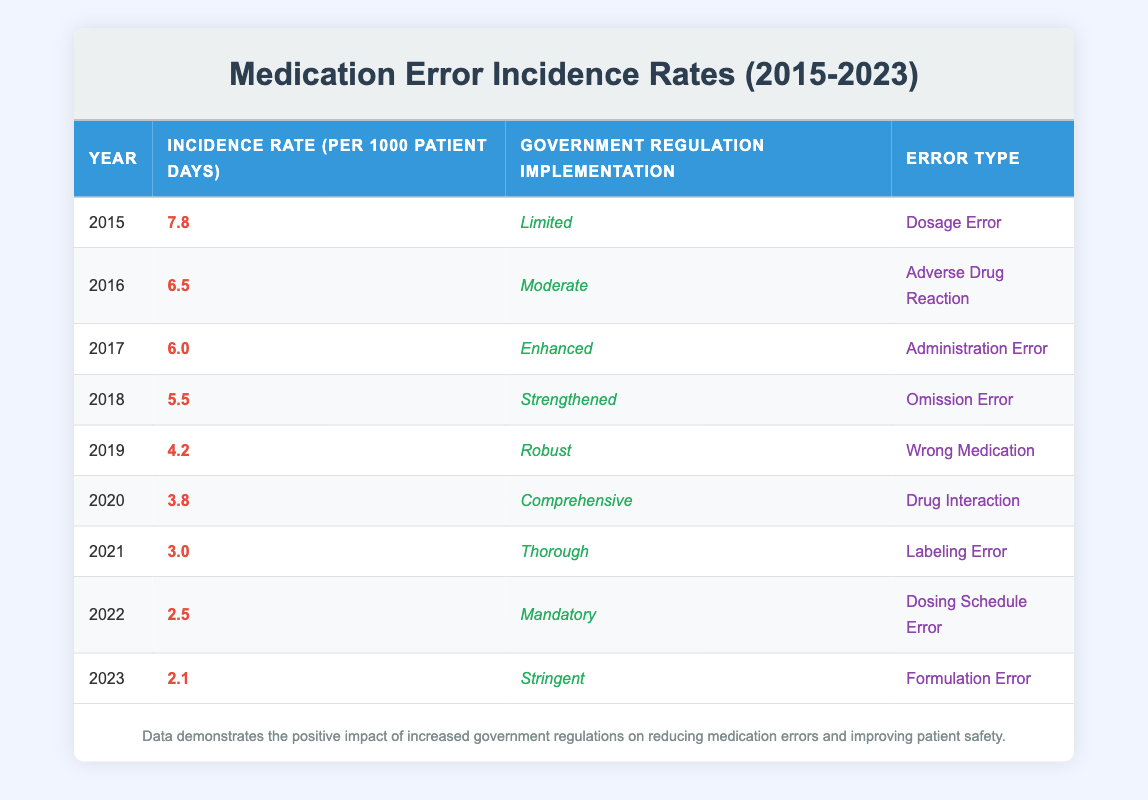What was the incidence rate of medication errors in 2015? The table shows that the incidence rate in 2015 is listed as 7.8 per 1000 patient days.
Answer: 7.8 Which year had the lowest incidence rate of medication errors? From the table, 2023 has the lowest incidence rate at 2.1 per 1000 patient days, which is lower than all other years listed.
Answer: 2023 Is there a correlation between the level of government regulation implementation and the incidence rate? Observing the data, as the level of government regulation implementation increases, the incidence rates generally decrease, indicating a likely inverse relationship.
Answer: Yes What was the difference in incidence rates between 2015 and 2020? To find this, subtract the 2020 rate (3.8) from the 2015 rate (7.8): 7.8 - 3.8 = 4.0. Thus, the difference is 4.0 per 1000 patient days.
Answer: 4.0 What is the type of medication error reported in 2019? The table indicates that the error type for the year 2019 is classified as "Wrong Medication."
Answer: Wrong Medication What is the average incidence rate from 2015 to 2023? First, sum the incidence rates: (7.8 + 6.5 + 6.0 + 5.5 + 4.2 + 3.8 + 3.0 + 2.5 + 2.1) = 39.6. There are 9 years of data, so the average is 39.6 / 9 = 4.4 per 1000 patient days.
Answer: 4.4 Did the implementation of the most stringent government regulation correlate with the highest incidence rates? By observing the table, the most stringent implementation in 2023 shows a low incidence rate of 2.1, thus contradicting the expectation that stringent regulations correlate with high incidence.
Answer: No How many types of medication errors were recorded in total across the years? The table lists distinct error types for each year, totaling 9 different types from 2015 to 2023.
Answer: 9 